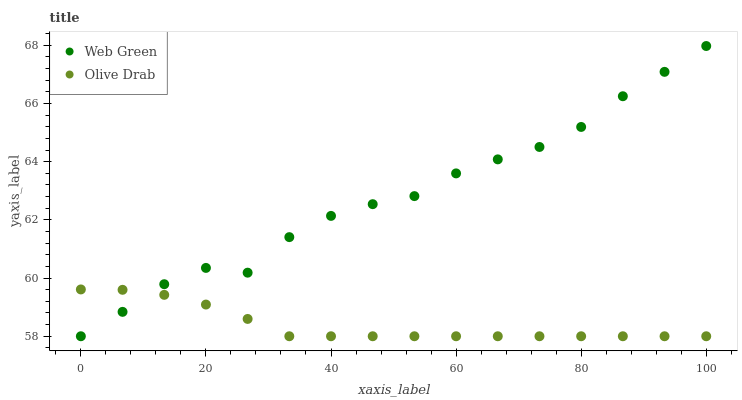Does Olive Drab have the minimum area under the curve?
Answer yes or no. Yes. Does Web Green have the maximum area under the curve?
Answer yes or no. Yes. Does Web Green have the minimum area under the curve?
Answer yes or no. No. Is Olive Drab the smoothest?
Answer yes or no. Yes. Is Web Green the roughest?
Answer yes or no. Yes. Is Web Green the smoothest?
Answer yes or no. No. Does Olive Drab have the lowest value?
Answer yes or no. Yes. Does Web Green have the highest value?
Answer yes or no. Yes. Does Olive Drab intersect Web Green?
Answer yes or no. Yes. Is Olive Drab less than Web Green?
Answer yes or no. No. Is Olive Drab greater than Web Green?
Answer yes or no. No. 